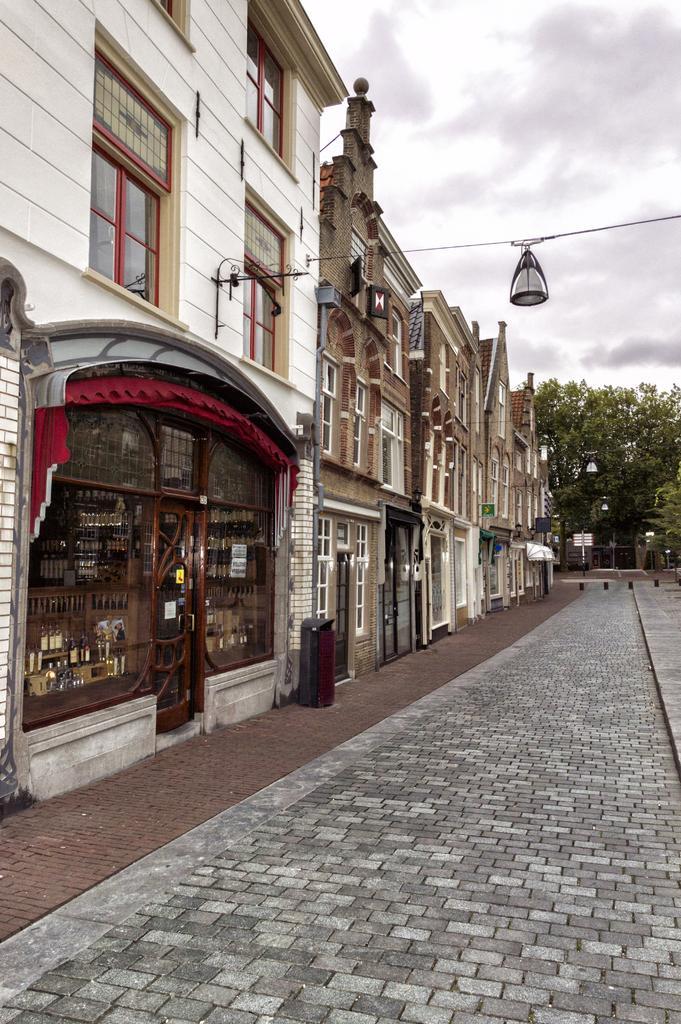Can you describe this image briefly? In this image I can see a building on the left hand side of the image. At the top of the image I can see the sky. At the bottom of the image I can see the pavement, on the right side of the image in the center position I can see some trees. 